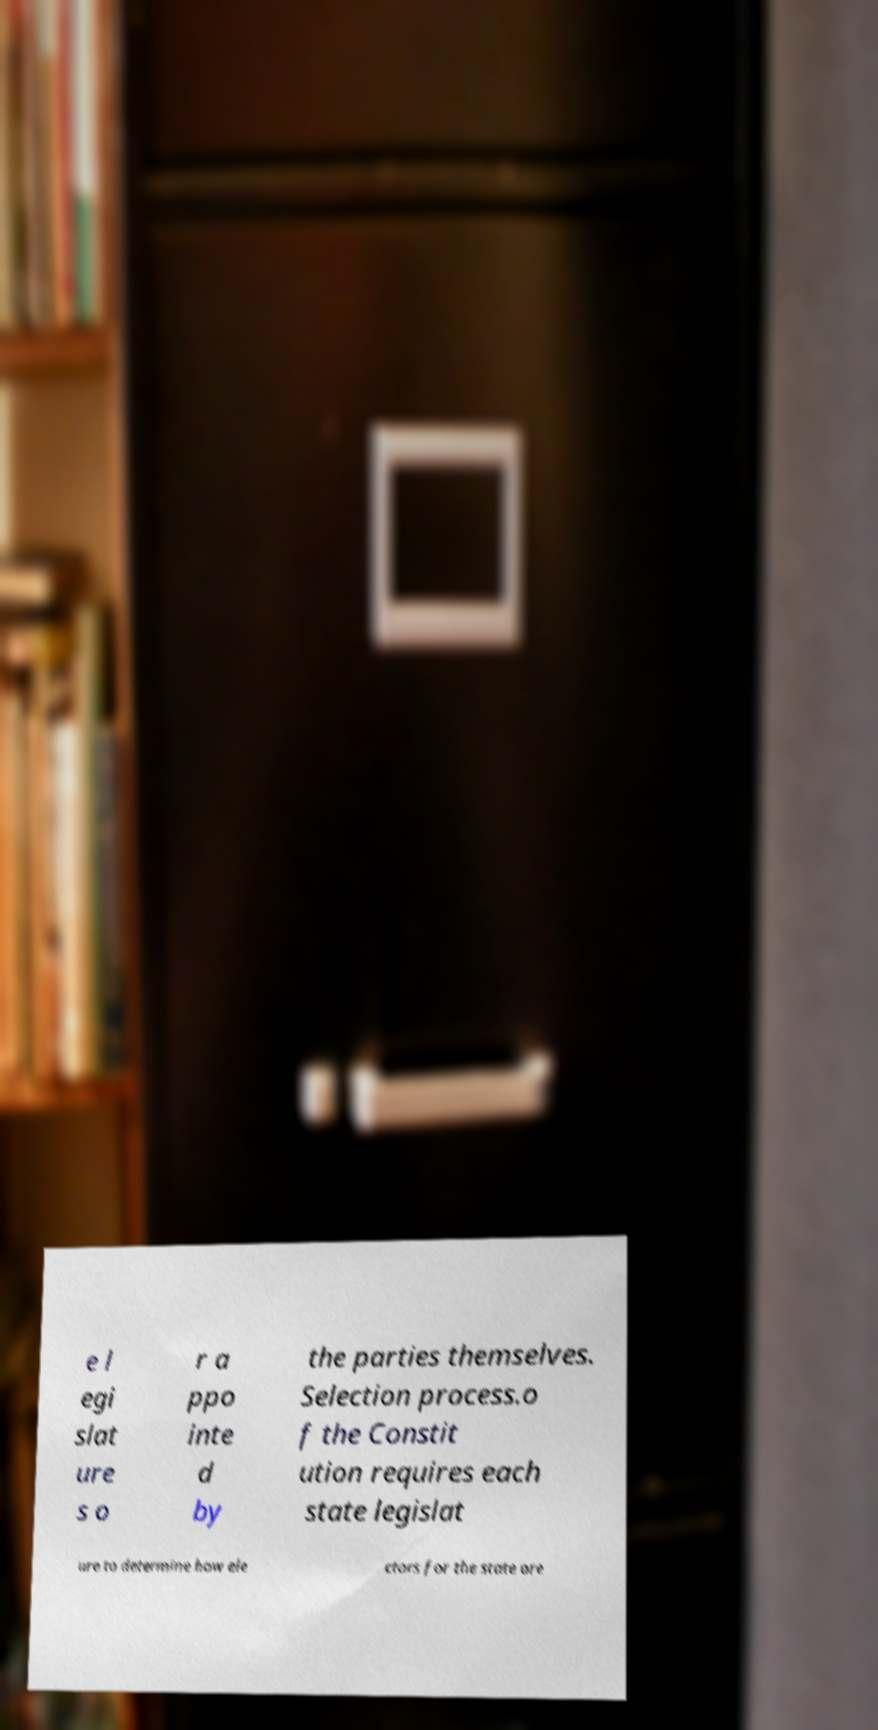For documentation purposes, I need the text within this image transcribed. Could you provide that? e l egi slat ure s o r a ppo inte d by the parties themselves. Selection process.o f the Constit ution requires each state legislat ure to determine how ele ctors for the state are 